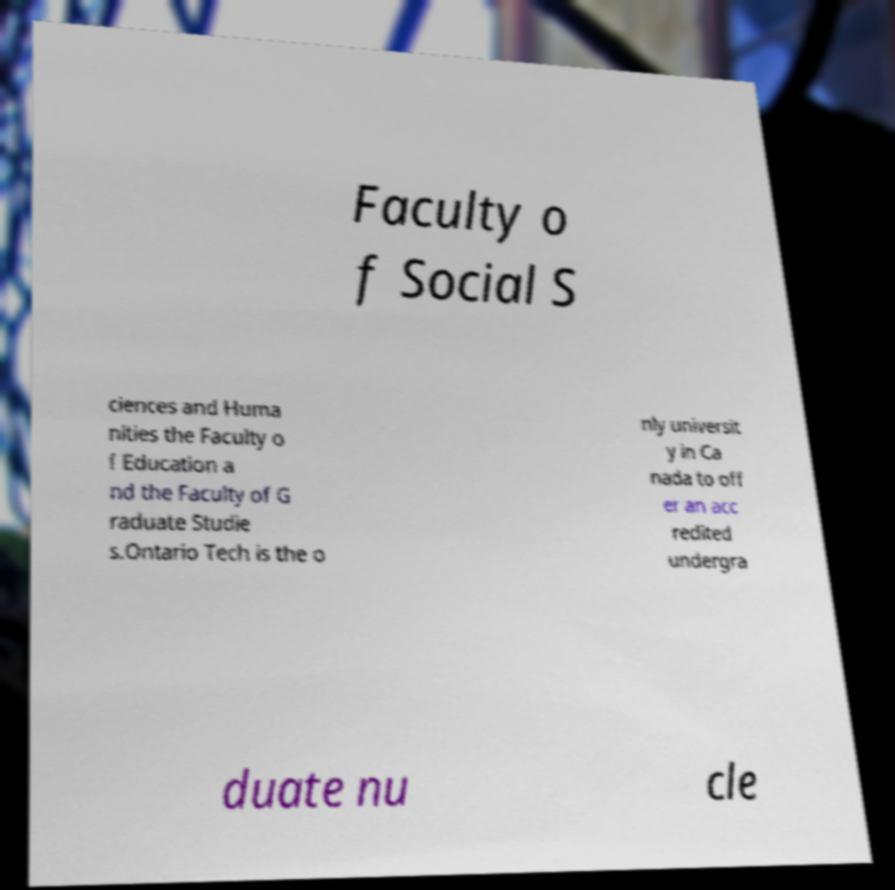I need the written content from this picture converted into text. Can you do that? Faculty o f Social S ciences and Huma nities the Faculty o f Education a nd the Faculty of G raduate Studie s.Ontario Tech is the o nly universit y in Ca nada to off er an acc redited undergra duate nu cle 